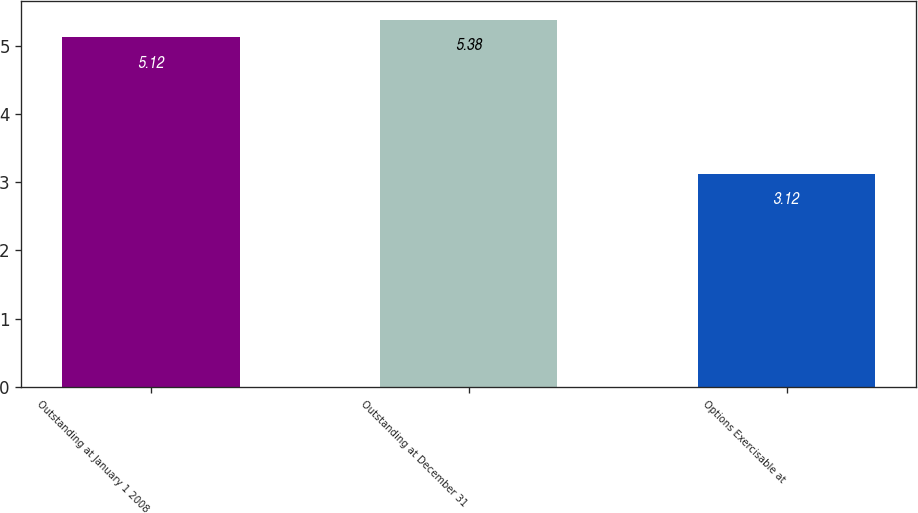Convert chart. <chart><loc_0><loc_0><loc_500><loc_500><bar_chart><fcel>Outstanding at January 1 2008<fcel>Outstanding at December 31<fcel>Options Exercisable at<nl><fcel>5.12<fcel>5.38<fcel>3.12<nl></chart> 